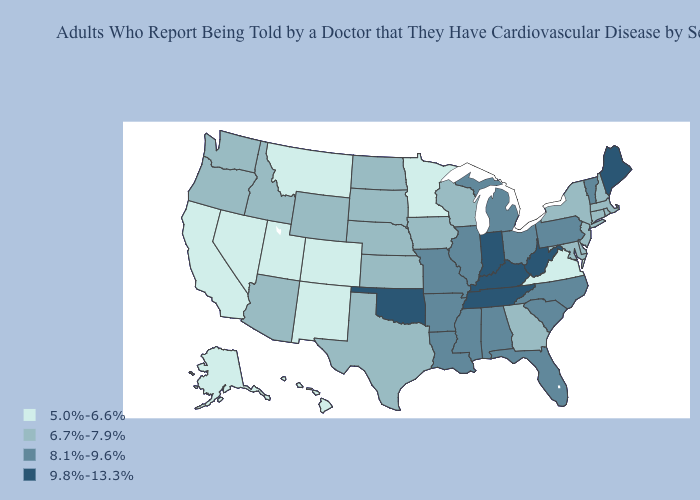Does New York have the highest value in the Northeast?
Be succinct. No. Which states hav the highest value in the Northeast?
Write a very short answer. Maine. What is the highest value in the West ?
Be succinct. 6.7%-7.9%. What is the value of Arizona?
Keep it brief. 6.7%-7.9%. Does Maryland have a lower value than Oklahoma?
Keep it brief. Yes. Which states have the lowest value in the USA?
Answer briefly. Alaska, California, Colorado, Hawaii, Minnesota, Montana, Nevada, New Mexico, Utah, Virginia. Which states have the lowest value in the West?
Give a very brief answer. Alaska, California, Colorado, Hawaii, Montana, Nevada, New Mexico, Utah. Is the legend a continuous bar?
Short answer required. No. What is the highest value in the MidWest ?
Write a very short answer. 9.8%-13.3%. Does the first symbol in the legend represent the smallest category?
Quick response, please. Yes. Does the first symbol in the legend represent the smallest category?
Write a very short answer. Yes. Does Delaware have the lowest value in the USA?
Give a very brief answer. No. Does Arizona have the same value as Maryland?
Write a very short answer. Yes. What is the highest value in states that border Missouri?
Keep it brief. 9.8%-13.3%. Does the first symbol in the legend represent the smallest category?
Be succinct. Yes. 